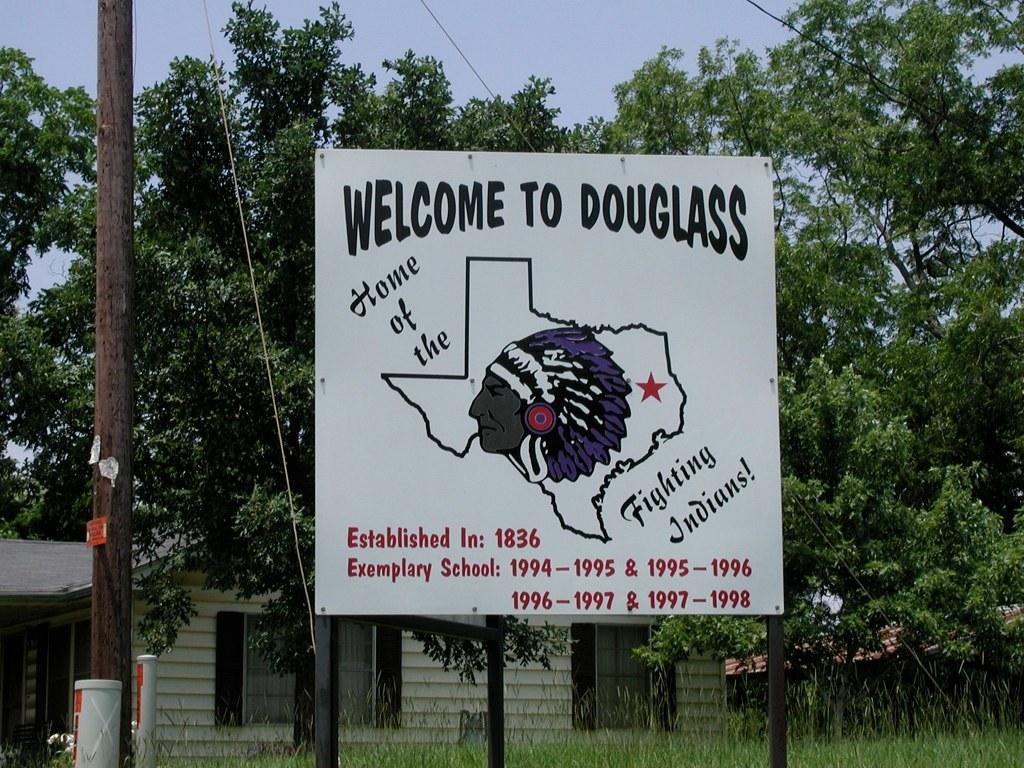What is the main structure in the image? There is a board on poles in the image. What type of terrain is visible in the image? There is grass visible in the image. What type of material is present in the image? There are ropes in the image. How many poles can be seen in the image? There is one pole visible in the image. What can be seen in the background of the image? There are trees, a house, and the sky visible in the background of the image. Reasoning: Let' Let's think step by step in order to produce the conversation. We start by identifying the main structure in the image, which is the board on poles. Then, we describe the terrain and materials present in the image, such as grass and ropes. Next, we count the number of poles visible in the image. Finally, we describe the background of the image, which includes trees, a house, and the sky. Absurd Question/Answer: What is the shape of the metal wilderness in the image? There is no metal wilderness present in the image. 